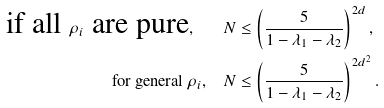<formula> <loc_0><loc_0><loc_500><loc_500>\text {if all } \rho _ { i } \text { are pure} , \quad & N \leq \left ( \frac { 5 } { 1 - \lambda _ { 1 } - \lambda _ { 2 } } \right ) ^ { 2 d } , \\ \text {for general } \rho _ { i } , \quad & N \leq \left ( \frac { 5 } { 1 - \lambda _ { 1 } - \lambda _ { 2 } } \right ) ^ { 2 d ^ { 2 } } .</formula> 